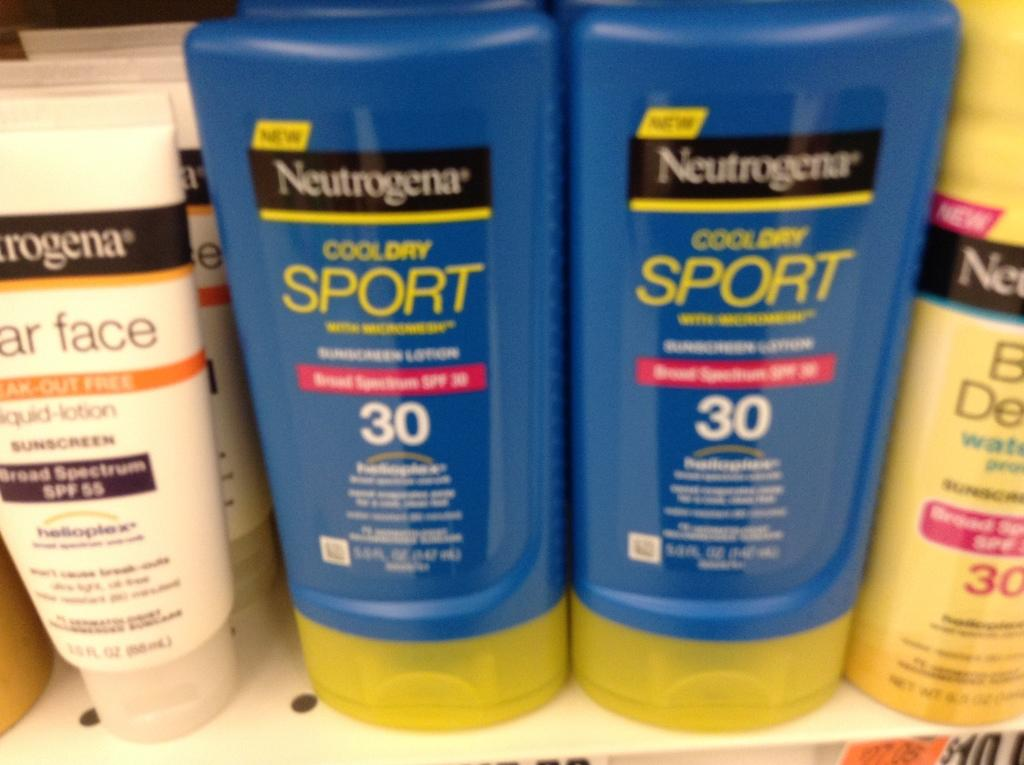<image>
Present a compact description of the photo's key features. Four bottles of various Neutrogena products, two blue, one yellow and one white. 